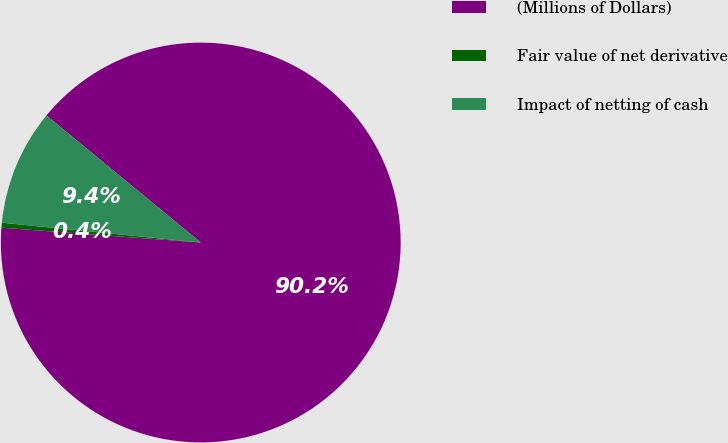<chart> <loc_0><loc_0><loc_500><loc_500><pie_chart><fcel>(Millions of Dollars)<fcel>Fair value of net derivative<fcel>Impact of netting of cash<nl><fcel>90.21%<fcel>0.4%<fcel>9.38%<nl></chart> 